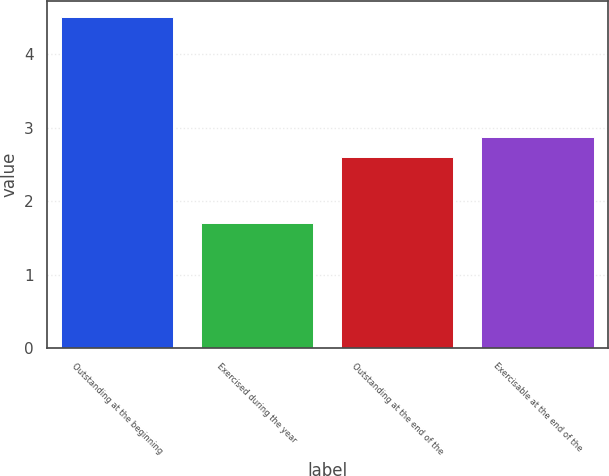<chart> <loc_0><loc_0><loc_500><loc_500><bar_chart><fcel>Outstanding at the beginning<fcel>Exercised during the year<fcel>Outstanding at the end of the<fcel>Exercisable at the end of the<nl><fcel>4.5<fcel>1.7<fcel>2.6<fcel>2.88<nl></chart> 